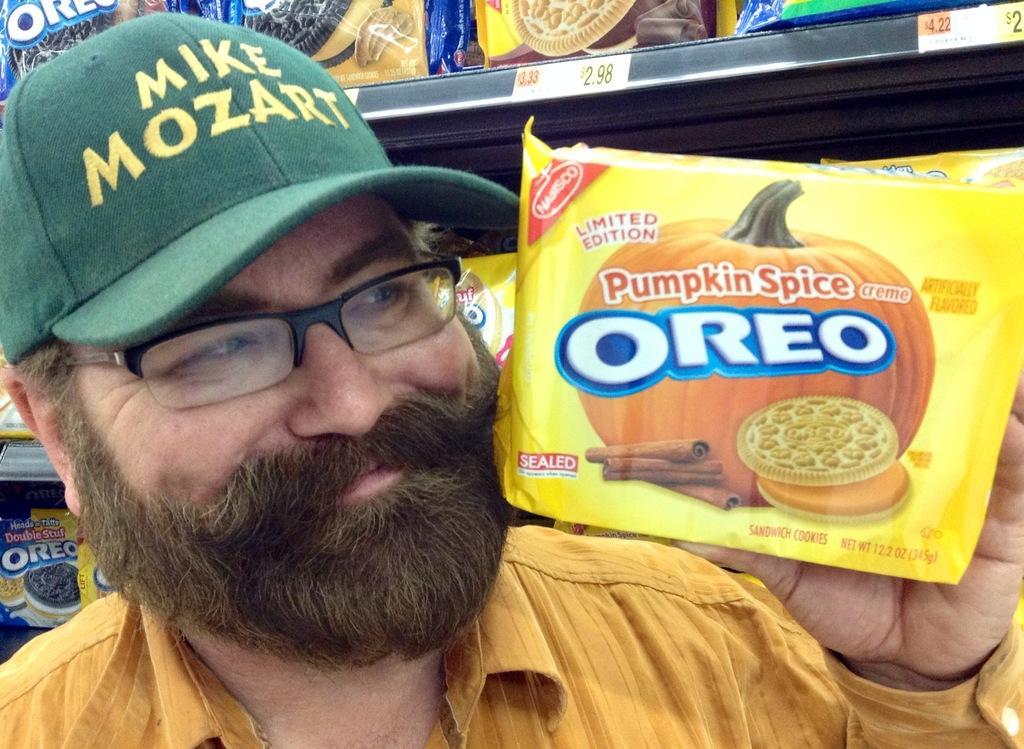Could you give a brief overview of what you see in this image? In this picture we can see a man with a cap holding a biscuit packet and smiling at someone. 